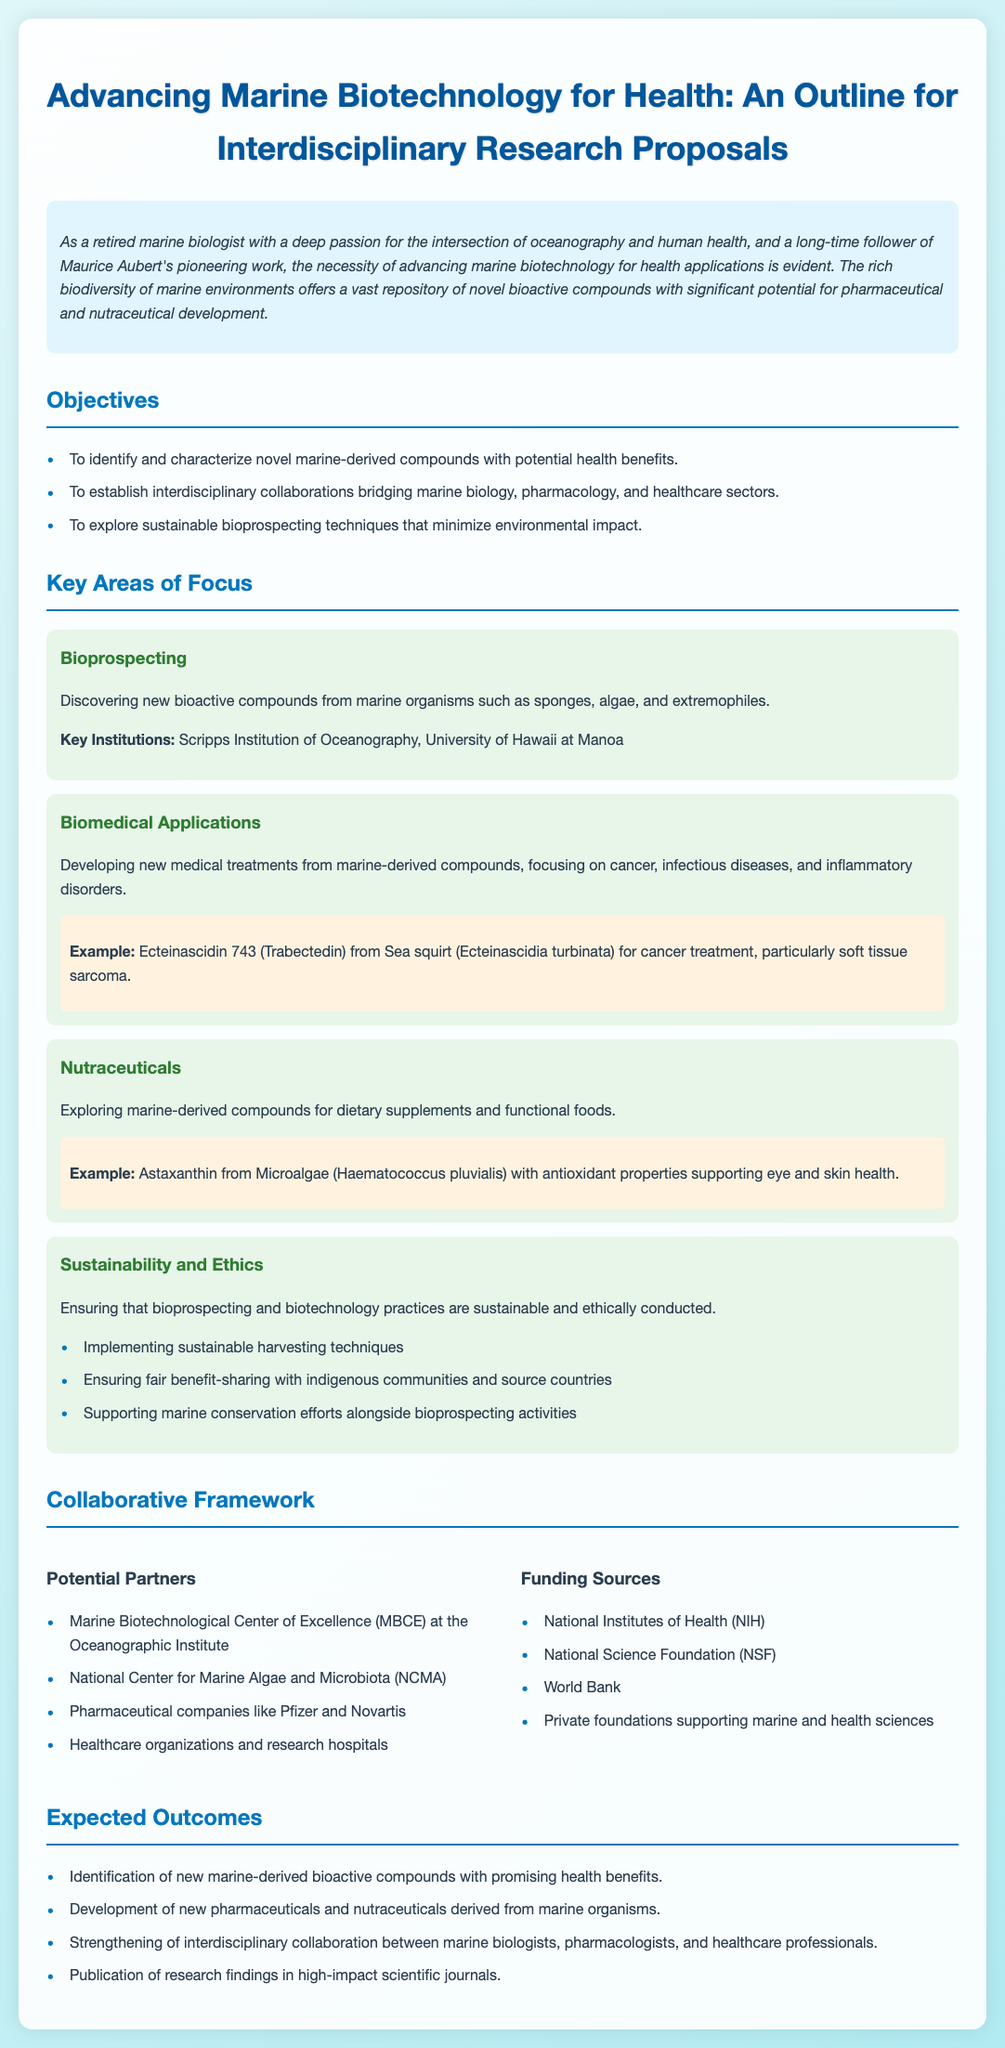What are the key objectives of the proposal? The key objectives are listed in the objectives section and include identifying novel marine-derived compounds, establishing collaborations, and exploring sustainable techniques.
Answer: Identifying novel marine-derived compounds, establishing collaborations, exploring sustainable techniques What is an example of a biomedical application mentioned? An example is provided in the biomedical applications section which describes the use of a marine-derived compound for cancer treatment.
Answer: Ecteinascidin 743 (Trabectedin) Which institution focuses on bioprospecting? The document mentions key institutions involved in bioprospecting efforts within the marine context.
Answer: Scripps Institution of Oceanography What are the expected outcomes of the research? The expected outcomes are listed in the document and provide multiple specific goals of the research project.
Answer: Identification of new marine-derived bioactive compounds What are potential funding sources for the proposed research? The funding sources are explicitly listed in the collaborative framework section.
Answer: National Institutes of Health (NIH) Which marine organism is cited as a source of antioxidant properties? The document includes specific examples of marine-derived compounds and their benefits, including their source organisms.
Answer: Haematococcus pluvialis What is the focus area that discusses sustainability practices? A specific focus area dedicated to sustainability and ethics is outlined, detailing the importance of environmentally-friendly practices.
Answer: Sustainability and Ethics Why is interdisciplinary collaboration emphasized in this proposal? The document outlines the need for collaboration across different fields of study for more effective outcomes, indicating the importance of diverse expertise.
Answer: Strengthening interdisciplinary collaboration 